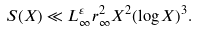<formula> <loc_0><loc_0><loc_500><loc_500>S ( X ) \ll L _ { \infty } ^ { \varepsilon } r _ { \infty } ^ { 2 } X ^ { 2 } ( \log X ) ^ { 3 } .</formula> 